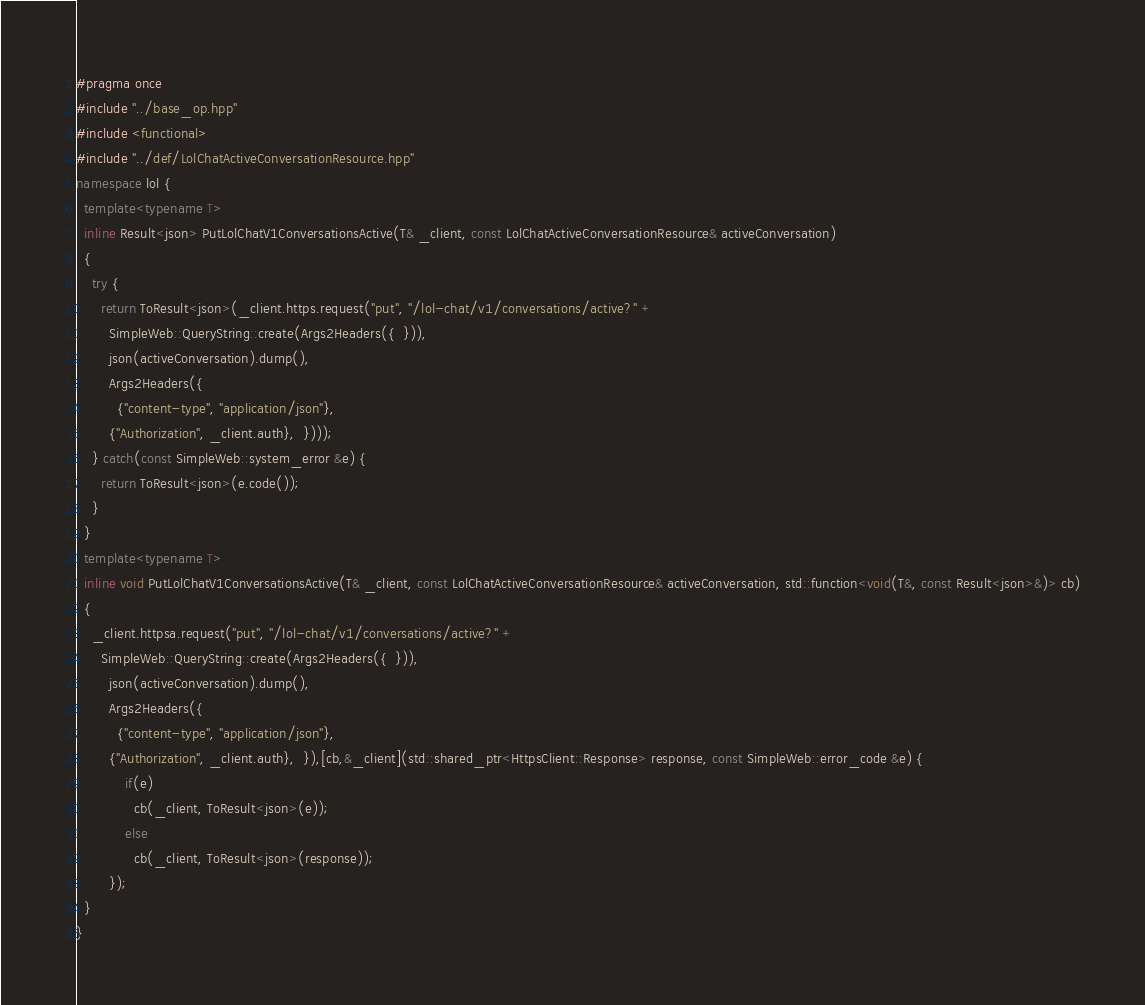Convert code to text. <code><loc_0><loc_0><loc_500><loc_500><_C++_>#pragma once
#include "../base_op.hpp"
#include <functional> 
#include "../def/LolChatActiveConversationResource.hpp"
namespace lol {
  template<typename T>
  inline Result<json> PutLolChatV1ConversationsActive(T& _client, const LolChatActiveConversationResource& activeConversation)
  {
    try {
      return ToResult<json>(_client.https.request("put", "/lol-chat/v1/conversations/active?" +
        SimpleWeb::QueryString::create(Args2Headers({  })), 
        json(activeConversation).dump(),
        Args2Headers({
          {"content-type", "application/json"},
        {"Authorization", _client.auth},  })));
    } catch(const SimpleWeb::system_error &e) {
      return ToResult<json>(e.code());
    }
  }
  template<typename T>
  inline void PutLolChatV1ConversationsActive(T& _client, const LolChatActiveConversationResource& activeConversation, std::function<void(T&, const Result<json>&)> cb)
  {
    _client.httpsa.request("put", "/lol-chat/v1/conversations/active?" +
      SimpleWeb::QueryString::create(Args2Headers({  })), 
        json(activeConversation).dump(),
        Args2Headers({
          {"content-type", "application/json"},
        {"Authorization", _client.auth},  }),[cb,&_client](std::shared_ptr<HttpsClient::Response> response, const SimpleWeb::error_code &e) {
            if(e)
              cb(_client, ToResult<json>(e));
            else
              cb(_client, ToResult<json>(response));
        });
  }
}</code> 